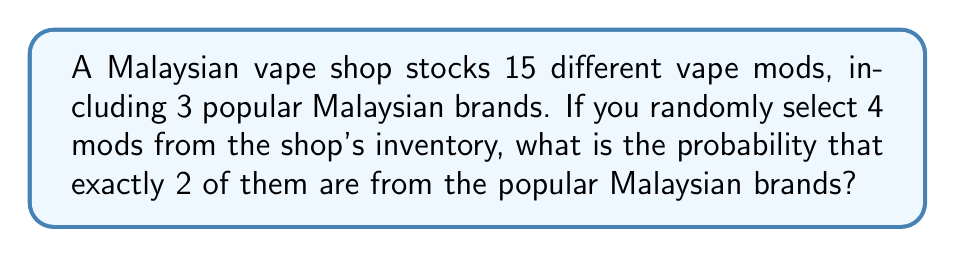Give your solution to this math problem. Let's approach this step-by-step using the concept of hypergeometric distribution:

1) We have a total of 15 vape mods, out of which 3 are from popular Malaysian brands.

2) We are selecting 4 mods randomly.

3) We want exactly 2 of these 4 to be from the popular Malaysian brands.

4) The probability is given by the formula:

   $$P(X=k) = \frac{\binom{K}{k} \binom{N-K}{n-k}}{\binom{N}{n}}$$

   Where:
   $N$ = total number of items (15 mods)
   $K$ = number of items in the desired category (3 Malaysian brand mods)
   $n$ = number of items drawn (4 mods)
   $k$ = number of desired items drawn (2 Malaysian brand mods)

5) Substituting our values:

   $$P(X=2) = \frac{\binom{3}{2} \binom{15-3}{4-2}}{\binom{15}{4}}$$

6) Calculating each combination:
   $\binom{3}{2} = 3$
   $\binom{12}{2} = 66$
   $\binom{15}{4} = 1365$

7) Substituting these values:

   $$P(X=2) = \frac{3 \times 66}{1365} = \frac{198}{1365}$$

8) Simplifying:

   $$P(X=2) = \frac{66}{455} \approx 0.1451$$
Answer: $\frac{66}{455}$ 